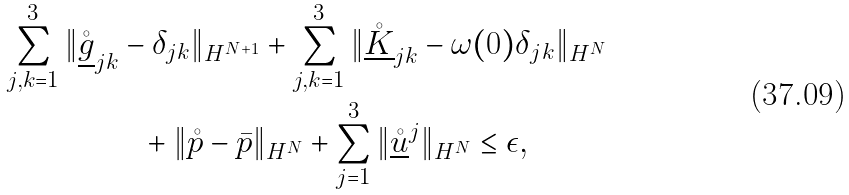<formula> <loc_0><loc_0><loc_500><loc_500>\sum _ { j , k = 1 } ^ { 3 } \| \mathring { \underline { g } } _ { j k } & - \delta _ { j k } \| _ { H ^ { N + 1 } } + \sum _ { j , k = 1 } ^ { 3 } \| \mathring { \underline { K } } _ { j k } - \omega ( 0 ) \delta _ { j k } \| _ { H ^ { N } } \\ & \ \ + \| \mathring { p } - \bar { p } \| _ { H ^ { N } } + \sum _ { j = 1 } ^ { 3 } \| \underline { \mathring { u } } ^ { j } \| _ { H ^ { N } } \leq \epsilon ,</formula> 